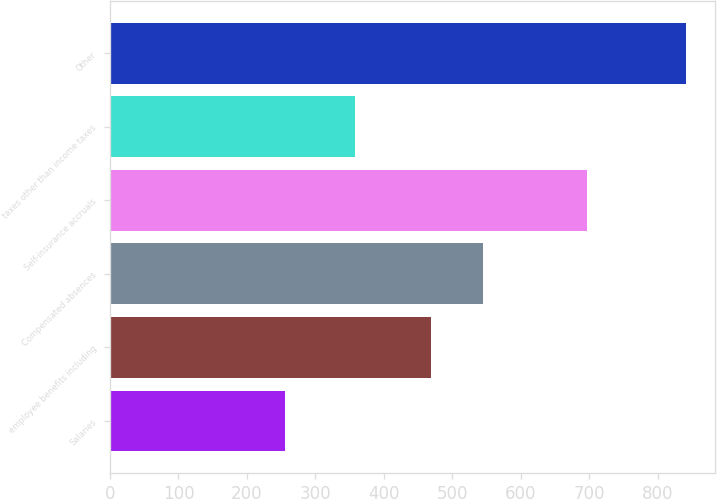Convert chart to OTSL. <chart><loc_0><loc_0><loc_500><loc_500><bar_chart><fcel>Salaries<fcel>employee benefits including<fcel>Compensated absences<fcel>Self-insurance accruals<fcel>taxes other than income taxes<fcel>Other<nl><fcel>256<fcel>468<fcel>544<fcel>696<fcel>357<fcel>841<nl></chart> 